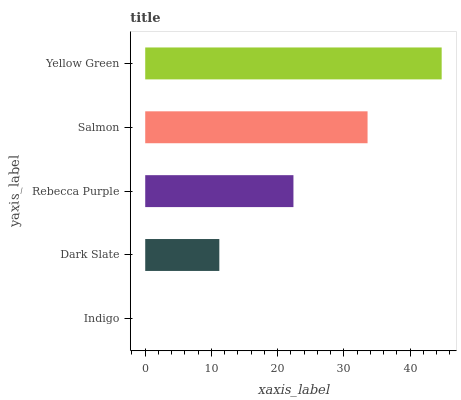Is Indigo the minimum?
Answer yes or no. Yes. Is Yellow Green the maximum?
Answer yes or no. Yes. Is Dark Slate the minimum?
Answer yes or no. No. Is Dark Slate the maximum?
Answer yes or no. No. Is Dark Slate greater than Indigo?
Answer yes or no. Yes. Is Indigo less than Dark Slate?
Answer yes or no. Yes. Is Indigo greater than Dark Slate?
Answer yes or no. No. Is Dark Slate less than Indigo?
Answer yes or no. No. Is Rebecca Purple the high median?
Answer yes or no. Yes. Is Rebecca Purple the low median?
Answer yes or no. Yes. Is Indigo the high median?
Answer yes or no. No. Is Salmon the low median?
Answer yes or no. No. 